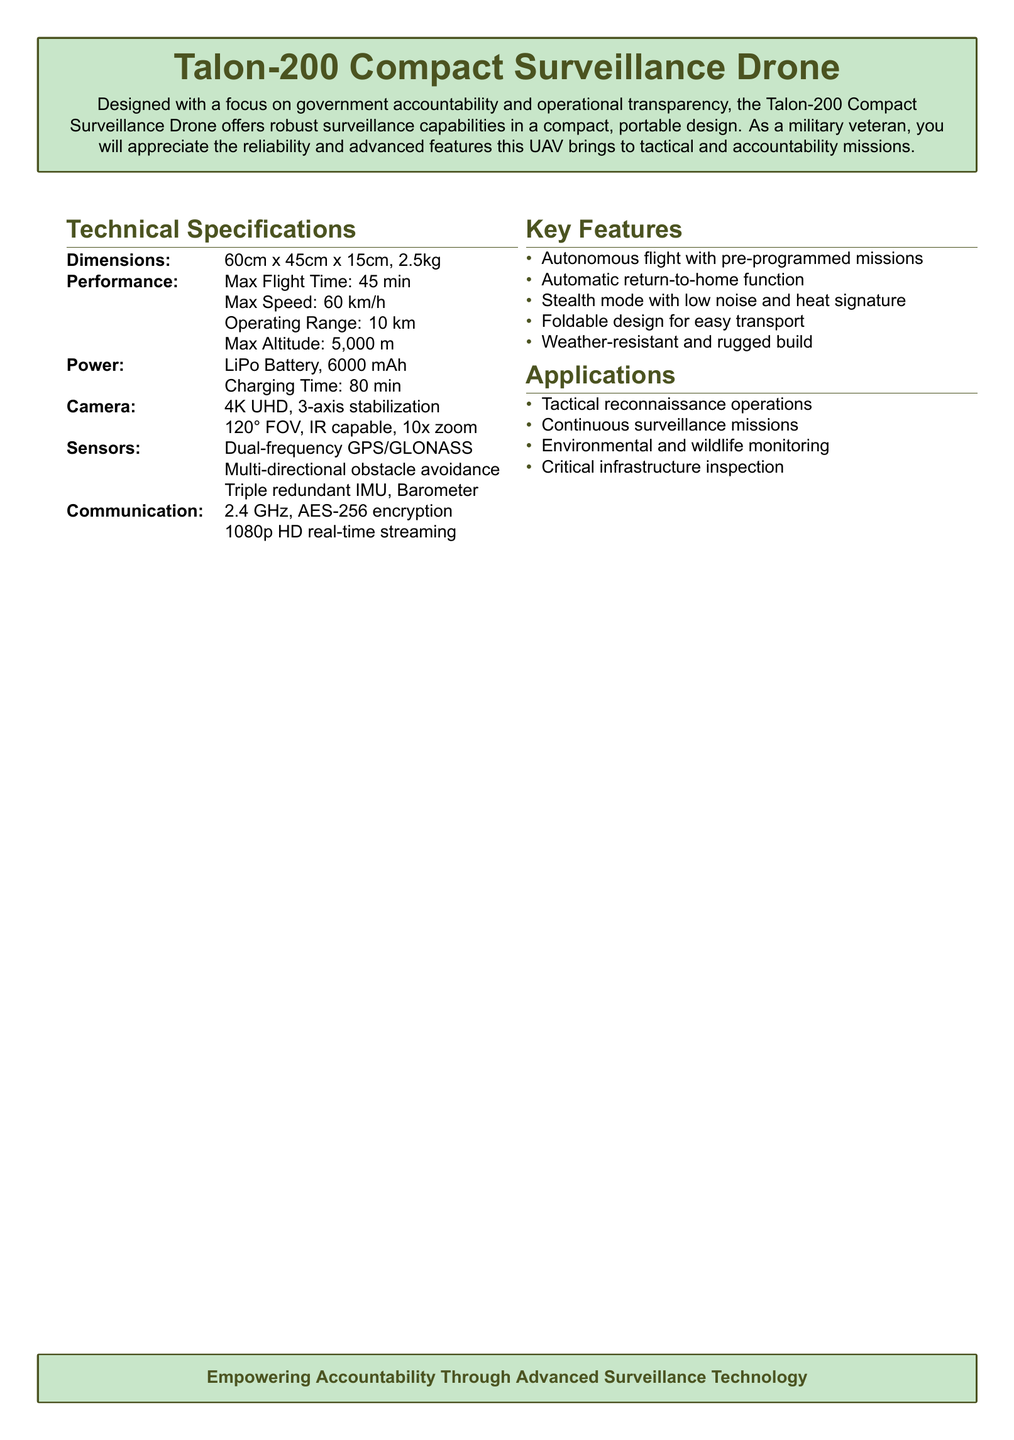What are the dimensions of the Talon-200? The dimensions are listed in the technical specifications section as 60cm x 45cm x 15cm.
Answer: 60cm x 45cm x 15cm What is the maximum flight time? The maximum flight time is specified as 45 minutes in the performance section.
Answer: 45 min What type of battery does the drone use? The type of battery is mentioned in the power section as LiPo.
Answer: LiPo Battery How fast can the Talon-200 fly? The maximum speed is provided in the performance part as 60 km/h.
Answer: 60 km/h What unique feature allows the drone to remain unnoticed? The document describes a feature that is stealth mode with low noise and heat signature.
Answer: Stealth mode Which application is mentioned for environmental monitoring? The applications section lists environmental and wildlife monitoring as one of the uses of the drone.
Answer: Environmental and wildlife monitoring What is the camera resolution of the Talon-200? The camera specification indicates a resolution of 4K UHD.
Answer: 4K UHD What kind of communication encryption is used? The communication section states that AES-256 encryption is employed.
Answer: AES-256 encryption How does the drone ensure operational reliability? The document mentions triple redundant IMU and other sensors for operational reliability.
Answer: Triple redundant IMU 